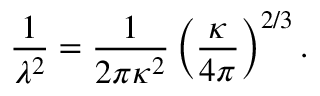Convert formula to latex. <formula><loc_0><loc_0><loc_500><loc_500>\frac { 1 } { \lambda ^ { 2 } } = \frac { 1 } { 2 \pi \kappa ^ { 2 } } \left ( \frac { \kappa } { 4 \pi } \right ) ^ { 2 / 3 } .</formula> 